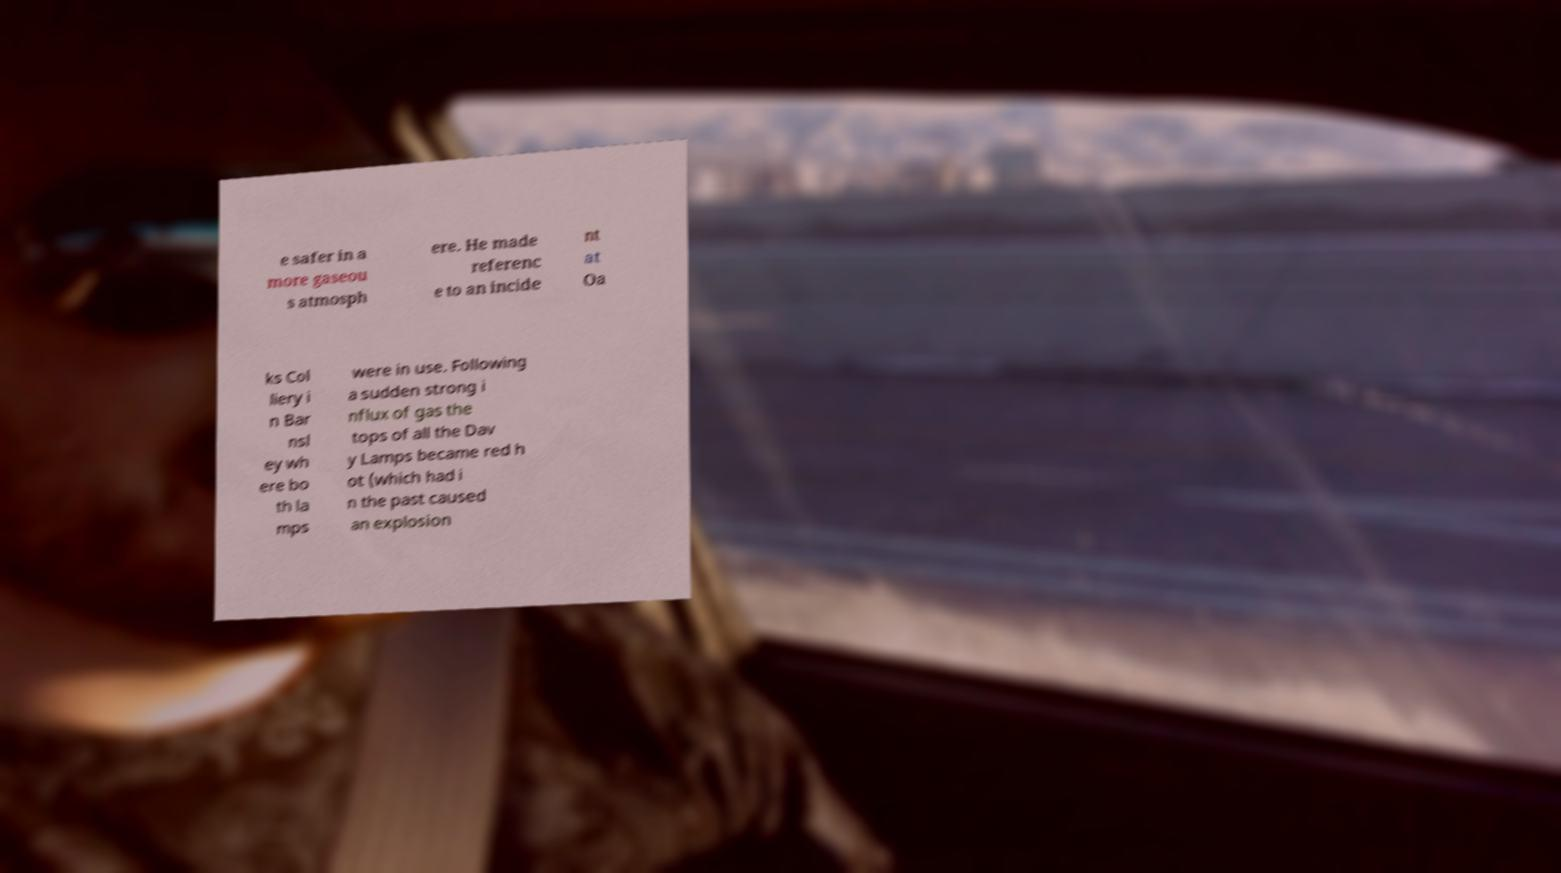Please read and relay the text visible in this image. What does it say? e safer in a more gaseou s atmosph ere. He made referenc e to an incide nt at Oa ks Col liery i n Bar nsl ey wh ere bo th la mps were in use. Following a sudden strong i nflux of gas the tops of all the Dav y Lamps became red h ot (which had i n the past caused an explosion 